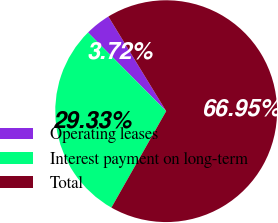<chart> <loc_0><loc_0><loc_500><loc_500><pie_chart><fcel>Operating leases<fcel>Interest payment on long-term<fcel>Total<nl><fcel>3.72%<fcel>29.33%<fcel>66.94%<nl></chart> 